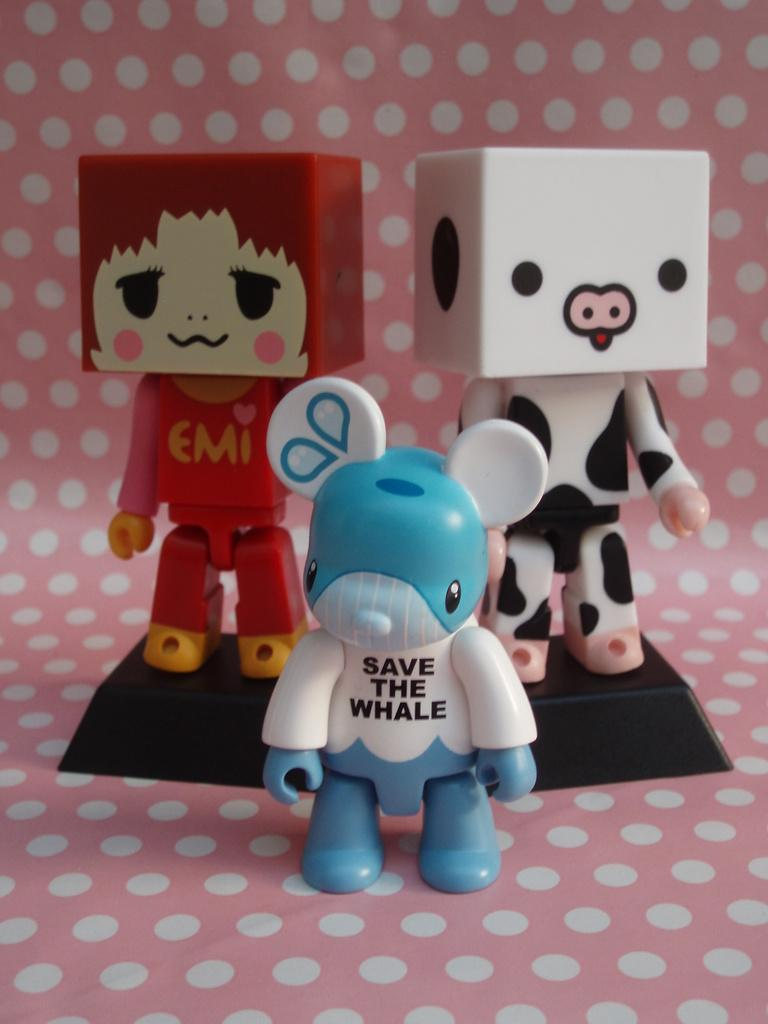How many toys are visible in the image? There are three toys in the image. What is the background or surface on which the toys are placed? The toys are on a white dotted surface. Are there any words or letters on the toys? Yes, there is text on the toys. Can you see an airplane flying in the background of the image? No, there is no airplane visible in the image. Are there any deer present in the image? No, there are no deer present in the image. 